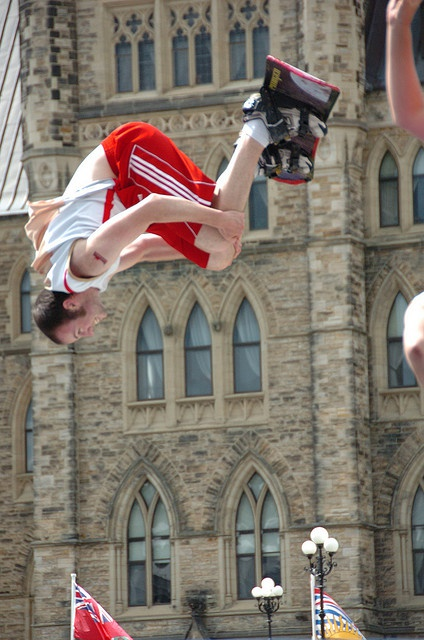Describe the objects in this image and their specific colors. I can see people in darkgray, white, gray, and brown tones, people in darkgray, brown, gray, and tan tones, and snowboard in darkgray, black, gray, and maroon tones in this image. 